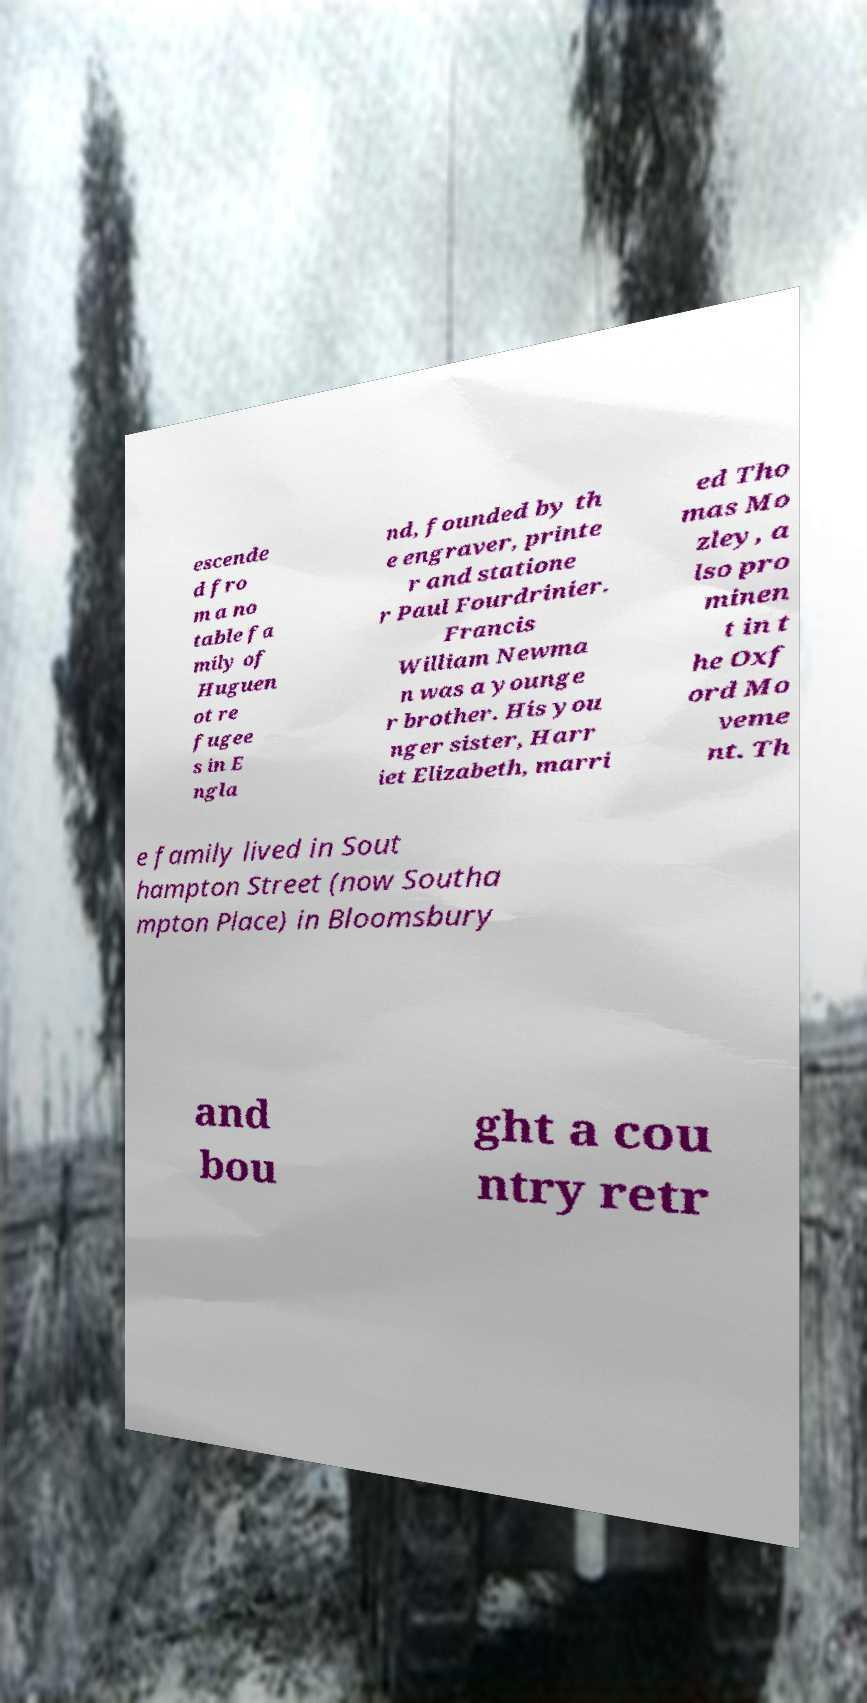There's text embedded in this image that I need extracted. Can you transcribe it verbatim? escende d fro m a no table fa mily of Huguen ot re fugee s in E ngla nd, founded by th e engraver, printe r and statione r Paul Fourdrinier. Francis William Newma n was a younge r brother. His you nger sister, Harr iet Elizabeth, marri ed Tho mas Mo zley, a lso pro minen t in t he Oxf ord Mo veme nt. Th e family lived in Sout hampton Street (now Southa mpton Place) in Bloomsbury and bou ght a cou ntry retr 